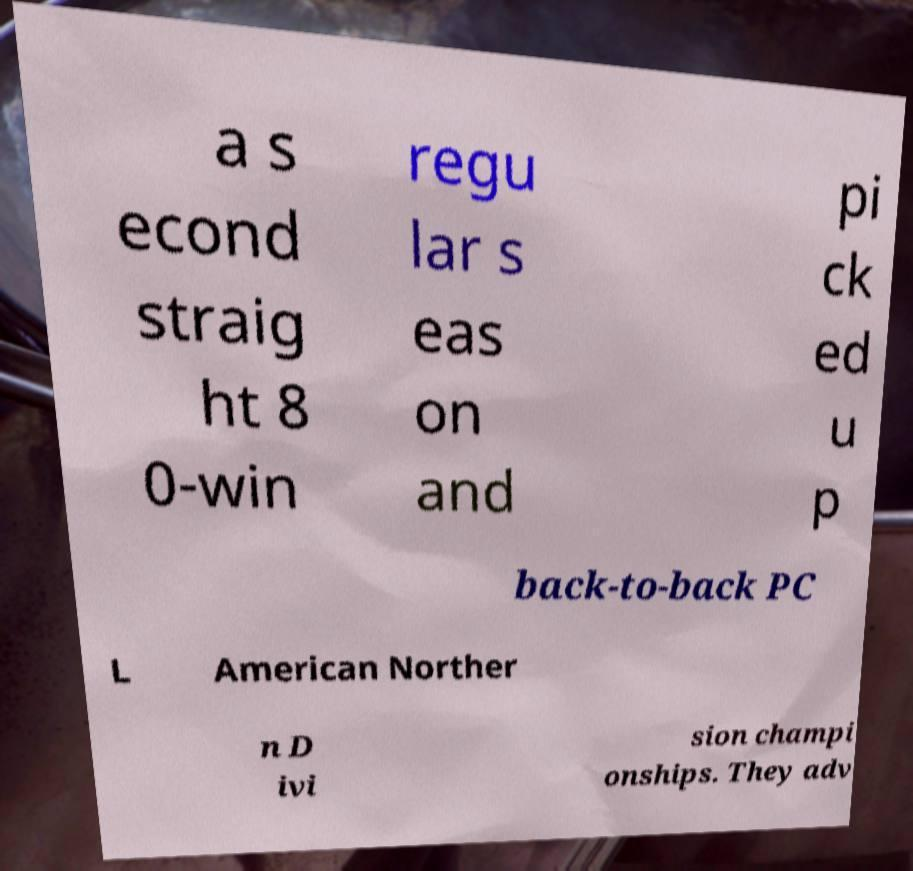There's text embedded in this image that I need extracted. Can you transcribe it verbatim? a s econd straig ht 8 0-win regu lar s eas on and pi ck ed u p back-to-back PC L American Norther n D ivi sion champi onships. They adv 